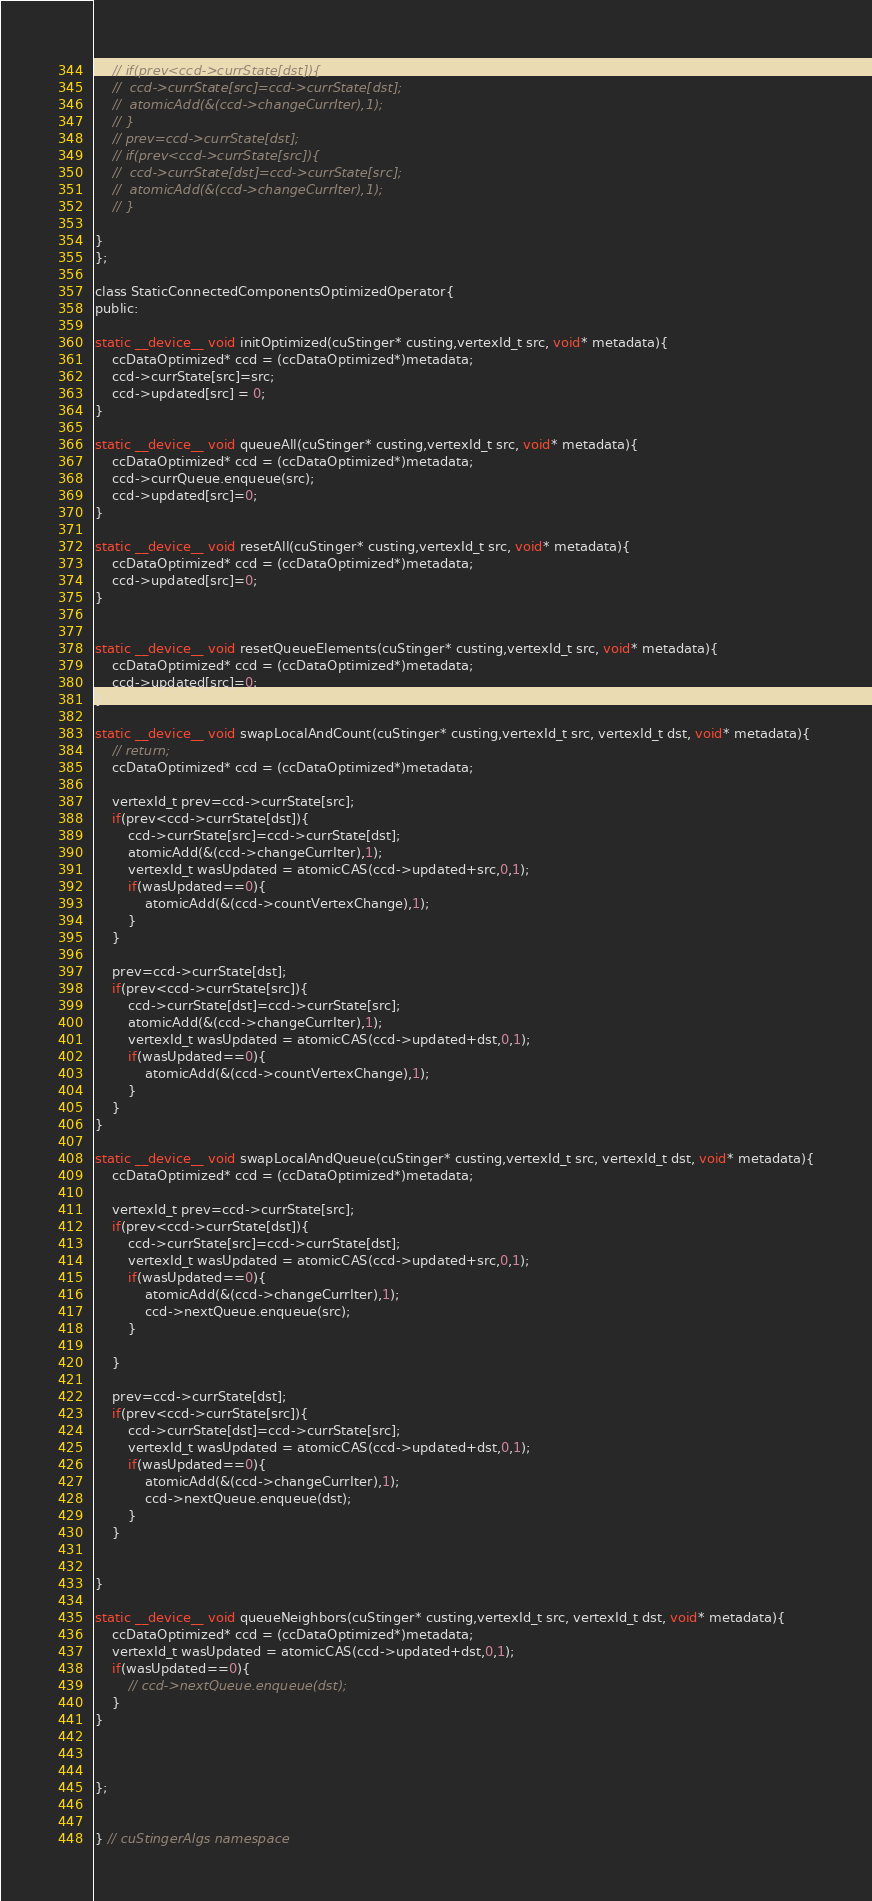Convert code to text. <code><loc_0><loc_0><loc_500><loc_500><_Cuda_>	// if(prev<ccd->currState[dst]){
	// 	ccd->currState[src]=ccd->currState[dst];
	// 	atomicAdd(&(ccd->changeCurrIter),1);
	// }
	// prev=ccd->currState[dst];
	// if(prev<ccd->currState[src]){
	// 	ccd->currState[dst]=ccd->currState[src];
	// 	atomicAdd(&(ccd->changeCurrIter),1);
	// }

}
};

class StaticConnectedComponentsOptimizedOperator{
public:

static __device__ void initOptimized(cuStinger* custing,vertexId_t src, void* metadata){
	ccDataOptimized* ccd = (ccDataOptimized*)metadata;
	ccd->currState[src]=src;
	ccd->updated[src] = 0;
}

static __device__ void queueAll(cuStinger* custing,vertexId_t src, void* metadata){
	ccDataOptimized* ccd = (ccDataOptimized*)metadata;
	ccd->currQueue.enqueue(src);
	ccd->updated[src]=0;
}

static __device__ void resetAll(cuStinger* custing,vertexId_t src, void* metadata){
	ccDataOptimized* ccd = (ccDataOptimized*)metadata;
	ccd->updated[src]=0;
}


static __device__ void resetQueueElements(cuStinger* custing,vertexId_t src, void* metadata){
	ccDataOptimized* ccd = (ccDataOptimized*)metadata;
	ccd->updated[src]=0;
}

static __device__ void swapLocalAndCount(cuStinger* custing,vertexId_t src, vertexId_t dst, void* metadata){
	// return;
	ccDataOptimized* ccd = (ccDataOptimized*)metadata;

	vertexId_t prev=ccd->currState[src];
	if(prev<ccd->currState[dst]){
		ccd->currState[src]=ccd->currState[dst];
		atomicAdd(&(ccd->changeCurrIter),1);
		vertexId_t wasUpdated = atomicCAS(ccd->updated+src,0,1);
		if(wasUpdated==0){
			atomicAdd(&(ccd->countVertexChange),1);
		}
	}

	prev=ccd->currState[dst];
	if(prev<ccd->currState[src]){
		ccd->currState[dst]=ccd->currState[src];
		atomicAdd(&(ccd->changeCurrIter),1);
		vertexId_t wasUpdated = atomicCAS(ccd->updated+dst,0,1);
		if(wasUpdated==0){
			atomicAdd(&(ccd->countVertexChange),1);
		}
	}
}

static __device__ void swapLocalAndQueue(cuStinger* custing,vertexId_t src, vertexId_t dst, void* metadata){
	ccDataOptimized* ccd = (ccDataOptimized*)metadata;

	vertexId_t prev=ccd->currState[src];
	if(prev<ccd->currState[dst]){
		ccd->currState[src]=ccd->currState[dst];
		vertexId_t wasUpdated = atomicCAS(ccd->updated+src,0,1);
		if(wasUpdated==0){
			atomicAdd(&(ccd->changeCurrIter),1);
			ccd->nextQueue.enqueue(src);
		}

	}

	prev=ccd->currState[dst];
	if(prev<ccd->currState[src]){
		ccd->currState[dst]=ccd->currState[src];
		vertexId_t wasUpdated = atomicCAS(ccd->updated+dst,0,1);
		if(wasUpdated==0){
			atomicAdd(&(ccd->changeCurrIter),1);			
			ccd->nextQueue.enqueue(dst);
		}
	}


}

static __device__ void queueNeighbors(cuStinger* custing,vertexId_t src, vertexId_t dst, void* metadata){
	ccDataOptimized* ccd = (ccDataOptimized*)metadata;
	vertexId_t wasUpdated = atomicCAS(ccd->updated+dst,0,1);
	if(wasUpdated==0){
		// ccd->nextQueue.enqueue(dst);
	}
}



};


} // cuStingerAlgs namespace</code> 